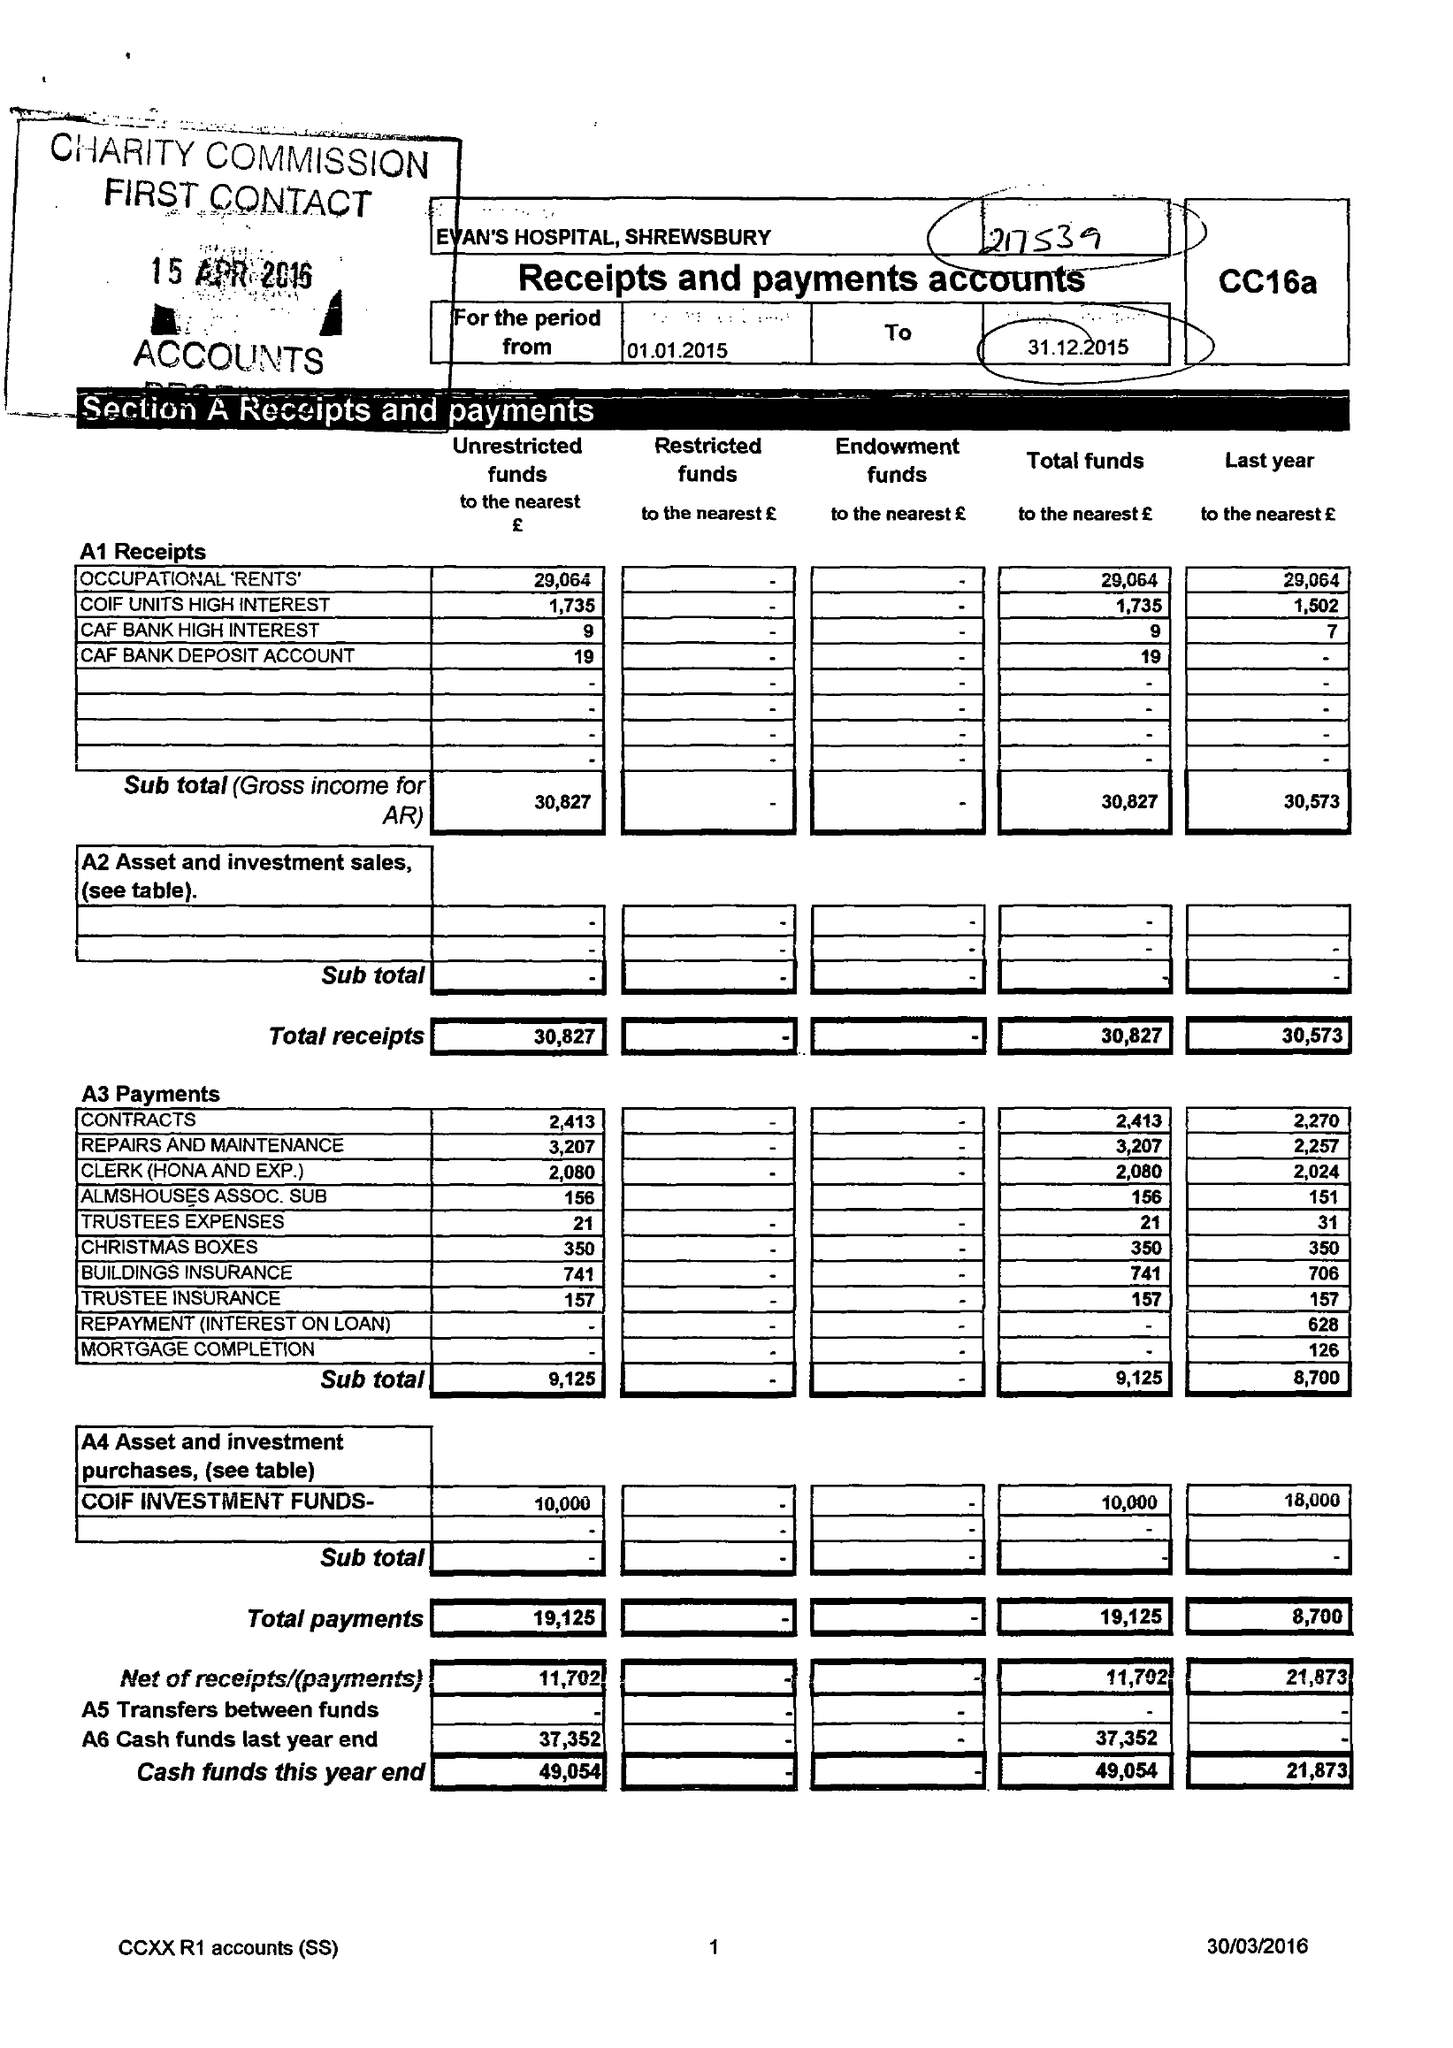What is the value for the spending_annually_in_british_pounds?
Answer the question using a single word or phrase. 19125.00 